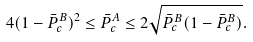Convert formula to latex. <formula><loc_0><loc_0><loc_500><loc_500>4 ( 1 - \bar { P } ^ { B } _ { c } ) ^ { 2 } \leq \bar { P } ^ { A } _ { c } \leq 2 \sqrt { \bar { P } ^ { B } _ { c } ( 1 - \bar { P } ^ { B } _ { c } ) } .</formula> 